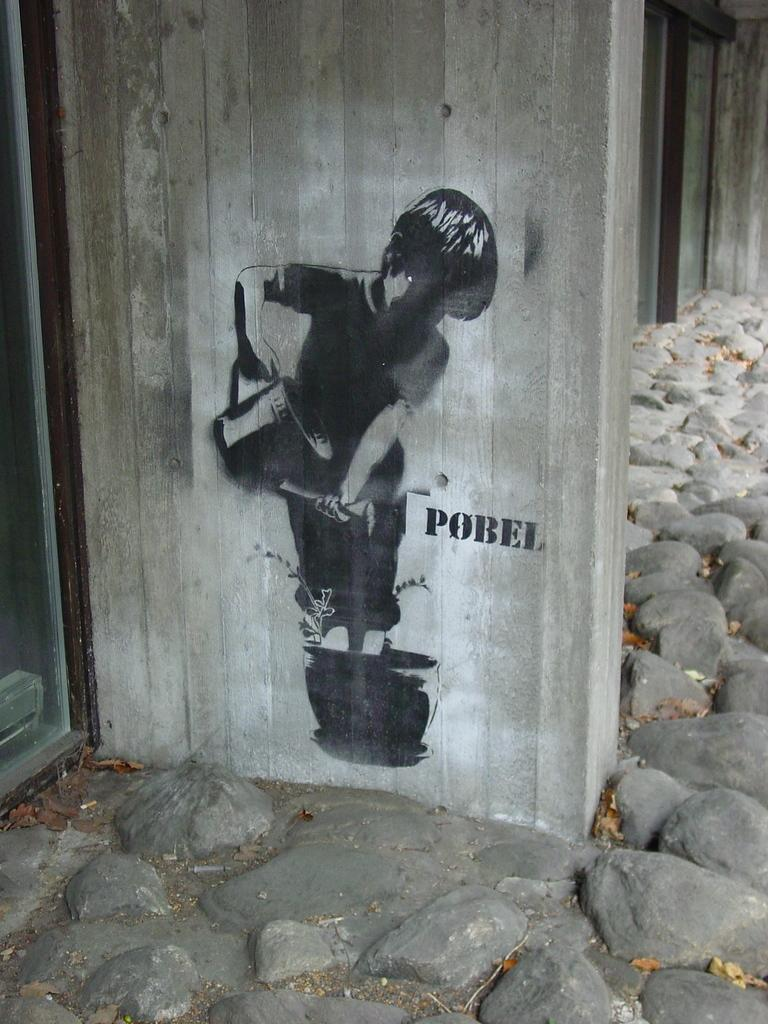What is depicted on the wall in the image? There is a drawing of a kid on the wall. What type of objects can be seen on the ground in the image? There are stones visible in the image. What type of stamp is being used to decorate the sweater in the image? There is no sweater or stamp present in the image; it only features a drawing of a kid on the wall and stones on the ground. 